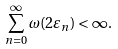Convert formula to latex. <formula><loc_0><loc_0><loc_500><loc_500>\sum _ { n = 0 } ^ { \infty } \omega ( 2 \varepsilon _ { n } ) < \infty .</formula> 